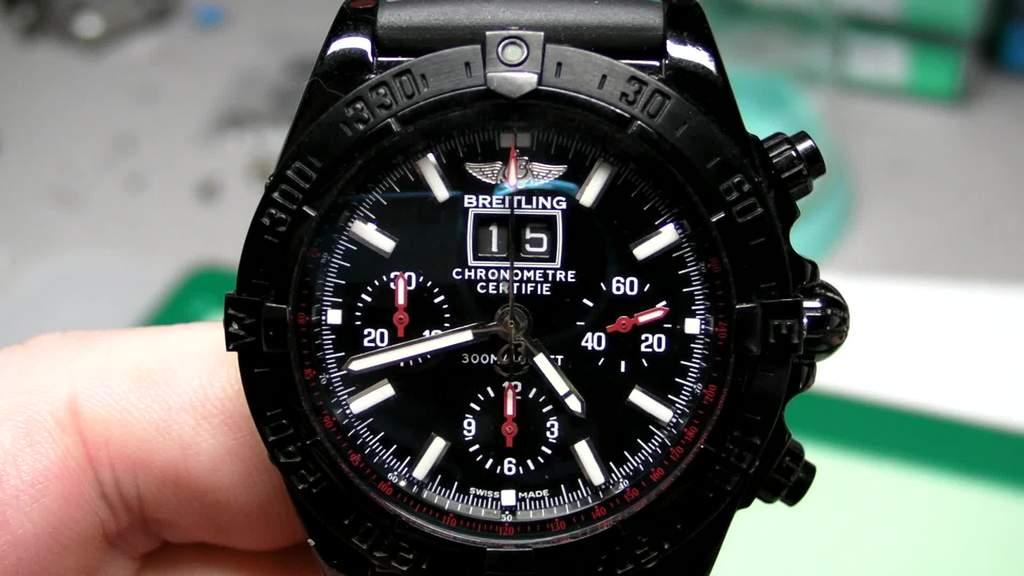What brand of watch is that?
Your answer should be very brief. Breitling. What time is ti?
Your response must be concise. 4:42. 